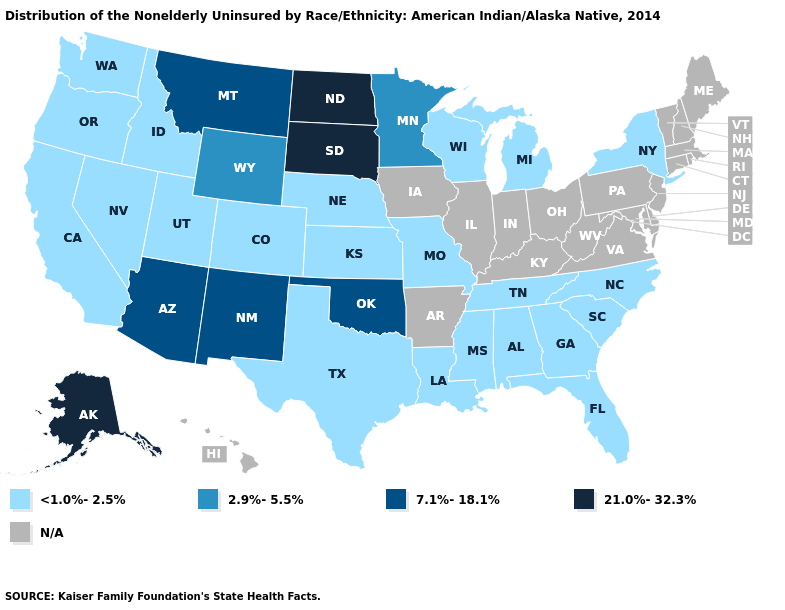Which states have the lowest value in the USA?
Quick response, please. Alabama, California, Colorado, Florida, Georgia, Idaho, Kansas, Louisiana, Michigan, Mississippi, Missouri, Nebraska, Nevada, New York, North Carolina, Oregon, South Carolina, Tennessee, Texas, Utah, Washington, Wisconsin. What is the lowest value in the USA?
Concise answer only. <1.0%-2.5%. Name the states that have a value in the range N/A?
Answer briefly. Arkansas, Connecticut, Delaware, Hawaii, Illinois, Indiana, Iowa, Kentucky, Maine, Maryland, Massachusetts, New Hampshire, New Jersey, Ohio, Pennsylvania, Rhode Island, Vermont, Virginia, West Virginia. Name the states that have a value in the range 7.1%-18.1%?
Answer briefly. Arizona, Montana, New Mexico, Oklahoma. What is the lowest value in the USA?
Give a very brief answer. <1.0%-2.5%. Name the states that have a value in the range 7.1%-18.1%?
Be succinct. Arizona, Montana, New Mexico, Oklahoma. Among the states that border Iowa , which have the highest value?
Be succinct. South Dakota. Does the first symbol in the legend represent the smallest category?
Write a very short answer. Yes. Is the legend a continuous bar?
Answer briefly. No. What is the lowest value in the MidWest?
Short answer required. <1.0%-2.5%. 